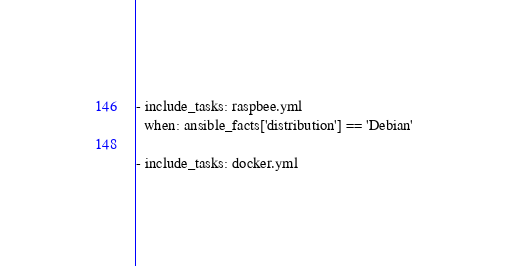<code> <loc_0><loc_0><loc_500><loc_500><_YAML_>- include_tasks: raspbee.yml
  when: ansible_facts['distribution'] == 'Debian'

- include_tasks: docker.yml
</code> 